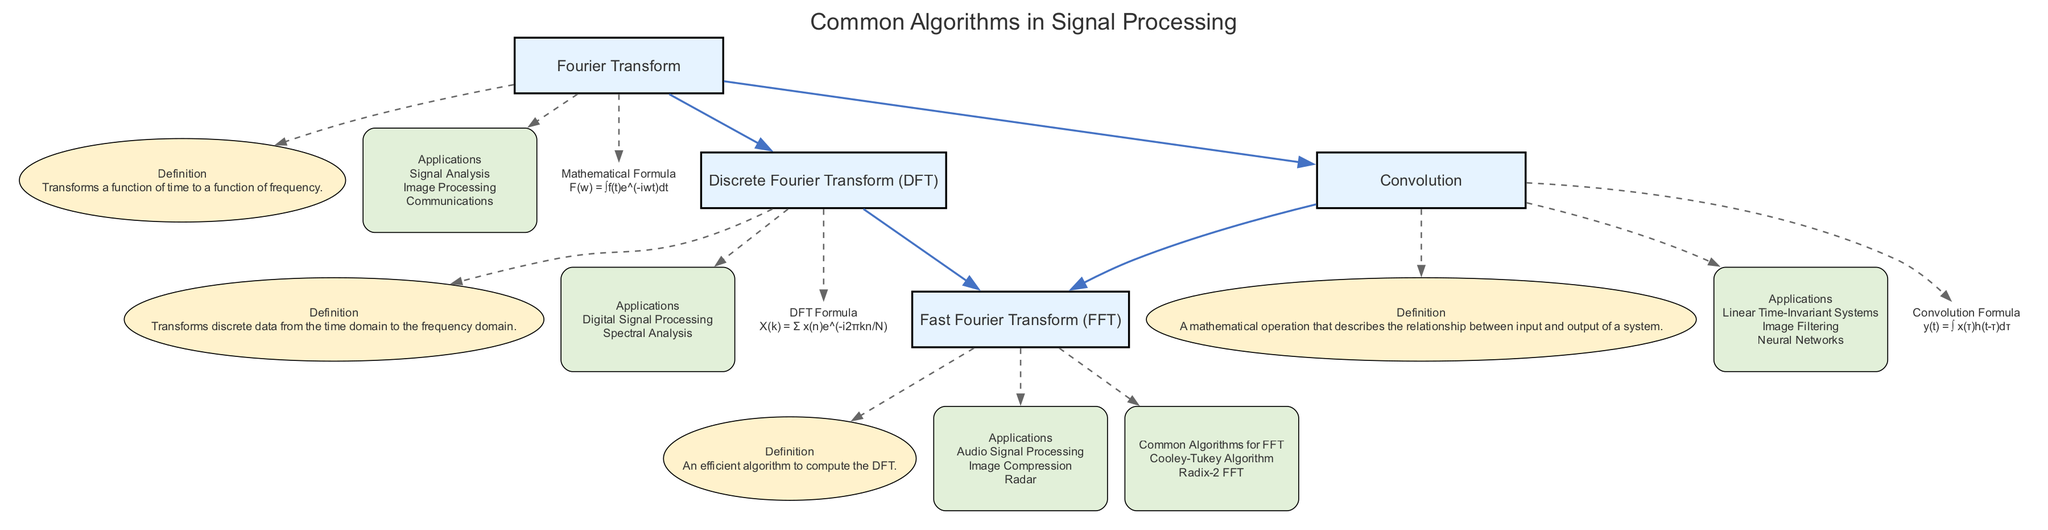What is the main function of the Fourier Transform? The Fourier Transform transforms a function of time to a function of frequency, which is indicated in the description of the "Fourier Transform" node in the diagram.
Answer: Transforms a function of time to a function of frequency How many topics are included in the diagram? The diagram displays four main topics: Fourier Transform, Discrete Fourier Transform, Fast Fourier Transform, and Convolution. Hence, the total count is four.
Answer: Four Which algorithm is an efficient way to compute the Discrete Fourier Transform? The diagram connects the Discrete Fourier Transform to the Fast Fourier Transform. This indicates that the Fast Fourier Transform is the efficient algorithm to compute the Discrete Fourier Transform.
Answer: Fast Fourier Transform What are two applications of Convolution mentioned in the diagram? The applications of Convolution include Linear Time-Invariant Systems and Image Filtering, both of which are listed under the "Applications" section for Convolution in the diagram.
Answer: Linear Time-Invariant Systems, Image Filtering Which two algorithms are mentioned under the Fast Fourier Transform as common algorithms? The common algorithms for Fast Fourier Transform featured in the diagram are Cooley-Tukey Algorithm and Radix-2 FFT. Hence, these two are the ones that are specified as examples.
Answer: Cooley-Tukey Algorithm, Radix-2 FFT How does Fourier Transform relate to Convolution based on the diagram? The diagram shows a direct connection from the Fourier Transform to Convolution. This indicates that Fourier Transform is used in relation to Convolution, suggesting they are interrelated in some processing techniques.
Answer: Related What is the formula represented in the Discrete Fourier Transform section? In the diagram, the formula for Discrete Fourier Transform is defined as X(k) = Σ x(n)e^(-i2πkn/N), which is clearly presented in the equation part of the Discrete Fourier Transform topic.
Answer: X(k) = Σ x(n)e^(-i2πkn/N) What are the two primary domains described for the Fourier Transform? The Fourier Transform works primarily in the time domain and transforms it into the frequency domain, as indicated by the definitions and relationships highlighted in the diagram.
Answer: Time domain, Frequency domain What property do all nodes share in terms of their visual representation? All main topic nodes in the diagram are displayed in a box shape with a filled color, while subnodes are presented as ellipses or boxes, illustrating a clear hierarchy in the representation.
Answer: Box shape with filled color 